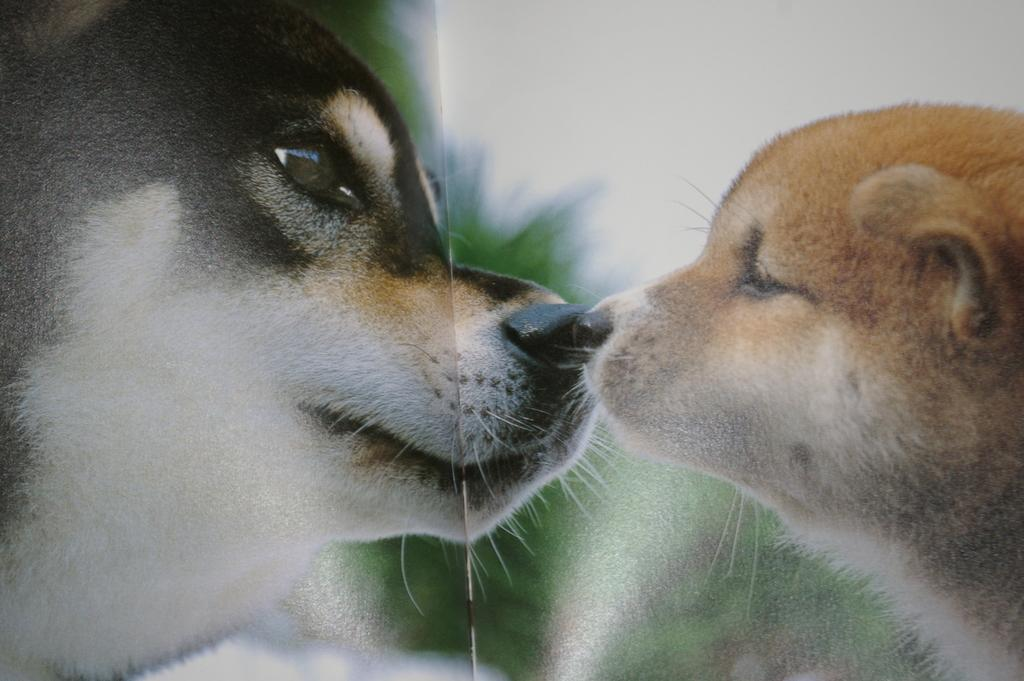What types of living organisms can be seen in the image? There are animals in the image. Can you describe the background of the image? The background of the image is blurry. What type of kitten is ploughing the field in the image? There is no kitten or field present in the image, and therefore no such activity can be observed. 